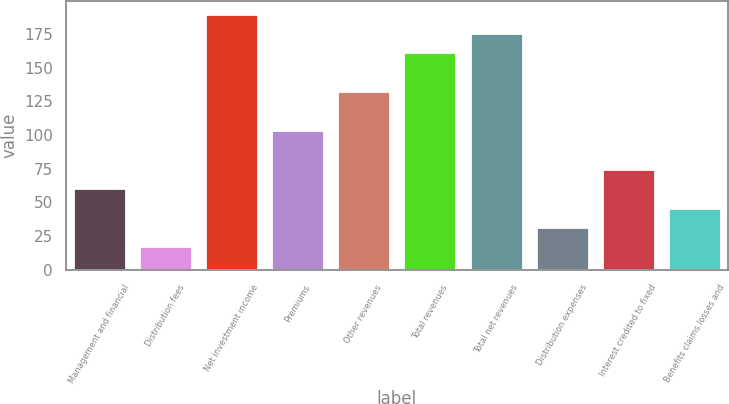Convert chart to OTSL. <chart><loc_0><loc_0><loc_500><loc_500><bar_chart><fcel>Management and financial<fcel>Distribution fees<fcel>Net investment income<fcel>Premiums<fcel>Other revenues<fcel>Total revenues<fcel>Total net revenues<fcel>Distribution expenses<fcel>Interest credited to fixed<fcel>Benefits claims losses and<nl><fcel>60.6<fcel>17.4<fcel>190.2<fcel>103.8<fcel>132.6<fcel>161.4<fcel>175.8<fcel>31.8<fcel>75<fcel>46.2<nl></chart> 